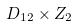<formula> <loc_0><loc_0><loc_500><loc_500>D _ { 1 2 } \times Z _ { 2 }</formula> 